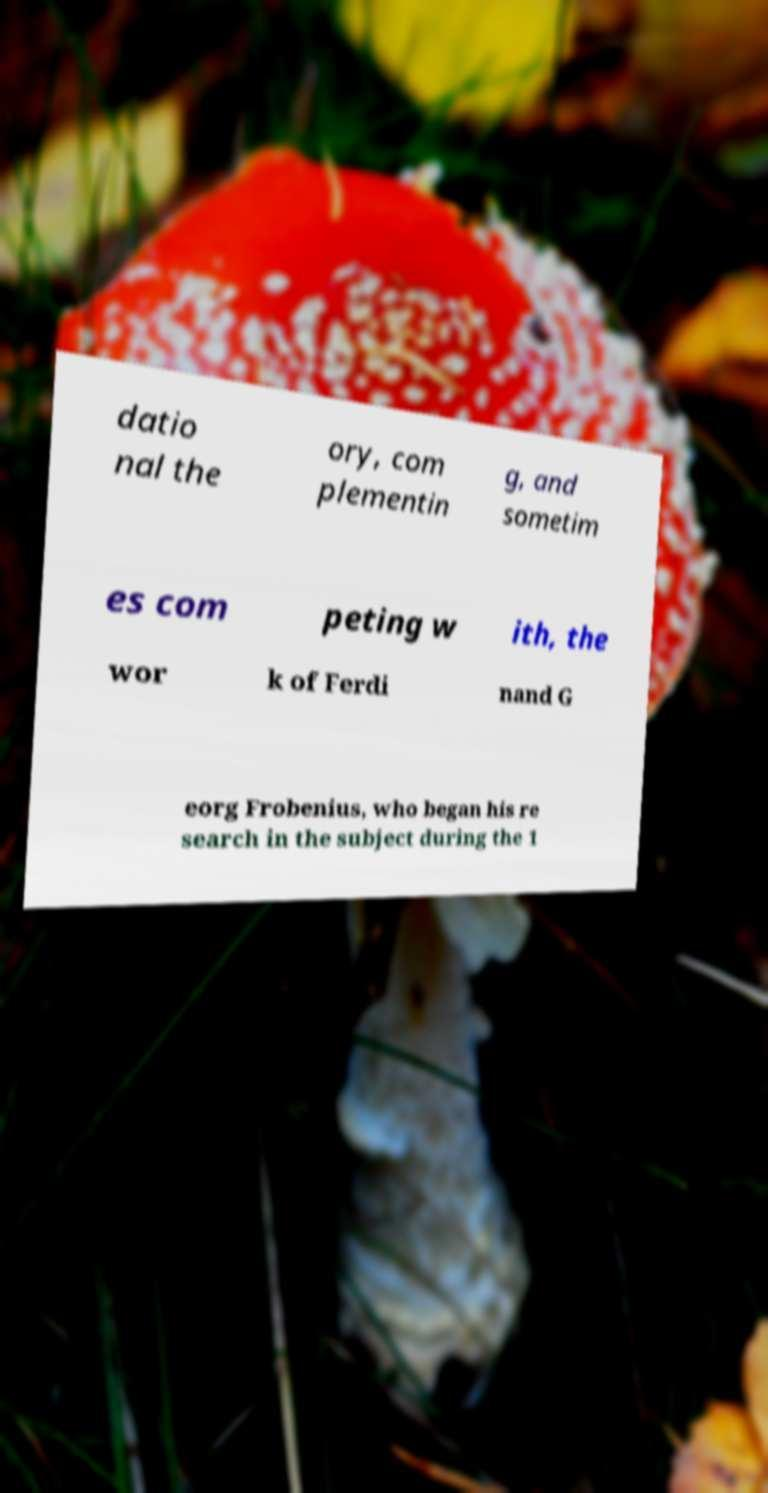For documentation purposes, I need the text within this image transcribed. Could you provide that? datio nal the ory, com plementin g, and sometim es com peting w ith, the wor k of Ferdi nand G eorg Frobenius, who began his re search in the subject during the 1 